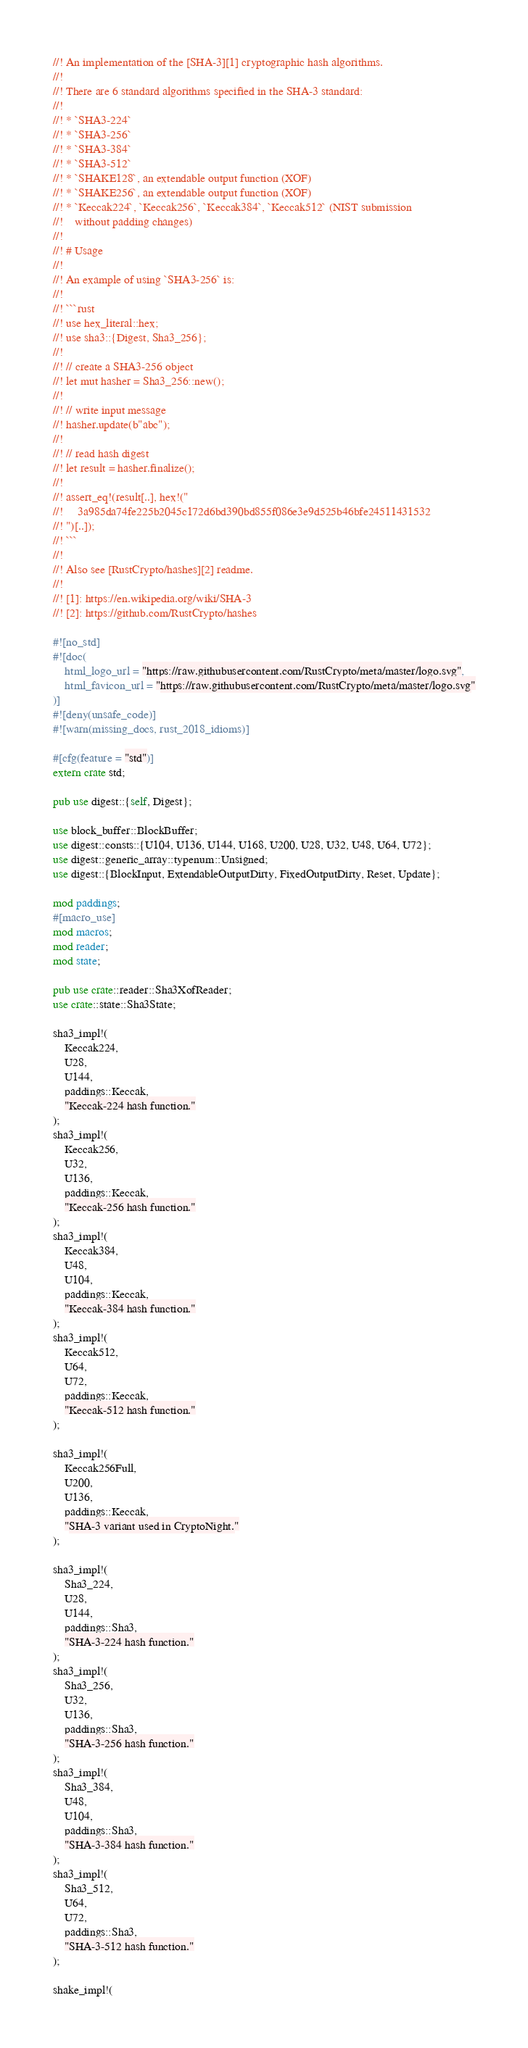Convert code to text. <code><loc_0><loc_0><loc_500><loc_500><_Rust_>//! An implementation of the [SHA-3][1] cryptographic hash algorithms.
//!
//! There are 6 standard algorithms specified in the SHA-3 standard:
//!
//! * `SHA3-224`
//! * `SHA3-256`
//! * `SHA3-384`
//! * `SHA3-512`
//! * `SHAKE128`, an extendable output function (XOF)
//! * `SHAKE256`, an extendable output function (XOF)
//! * `Keccak224`, `Keccak256`, `Keccak384`, `Keccak512` (NIST submission
//!    without padding changes)
//!
//! # Usage
//!
//! An example of using `SHA3-256` is:
//!
//! ```rust
//! use hex_literal::hex;
//! use sha3::{Digest, Sha3_256};
//!
//! // create a SHA3-256 object
//! let mut hasher = Sha3_256::new();
//!
//! // write input message
//! hasher.update(b"abc");
//!
//! // read hash digest
//! let result = hasher.finalize();
//!
//! assert_eq!(result[..], hex!("
//!     3a985da74fe225b2045c172d6bd390bd855f086e3e9d525b46bfe24511431532
//! ")[..]);
//! ```
//!
//! Also see [RustCrypto/hashes][2] readme.
//!
//! [1]: https://en.wikipedia.org/wiki/SHA-3
//! [2]: https://github.com/RustCrypto/hashes

#![no_std]
#![doc(
    html_logo_url = "https://raw.githubusercontent.com/RustCrypto/meta/master/logo.svg",
    html_favicon_url = "https://raw.githubusercontent.com/RustCrypto/meta/master/logo.svg"
)]
#![deny(unsafe_code)]
#![warn(missing_docs, rust_2018_idioms)]

#[cfg(feature = "std")]
extern crate std;

pub use digest::{self, Digest};

use block_buffer::BlockBuffer;
use digest::consts::{U104, U136, U144, U168, U200, U28, U32, U48, U64, U72};
use digest::generic_array::typenum::Unsigned;
use digest::{BlockInput, ExtendableOutputDirty, FixedOutputDirty, Reset, Update};

mod paddings;
#[macro_use]
mod macros;
mod reader;
mod state;

pub use crate::reader::Sha3XofReader;
use crate::state::Sha3State;

sha3_impl!(
    Keccak224,
    U28,
    U144,
    paddings::Keccak,
    "Keccak-224 hash function."
);
sha3_impl!(
    Keccak256,
    U32,
    U136,
    paddings::Keccak,
    "Keccak-256 hash function."
);
sha3_impl!(
    Keccak384,
    U48,
    U104,
    paddings::Keccak,
    "Keccak-384 hash function."
);
sha3_impl!(
    Keccak512,
    U64,
    U72,
    paddings::Keccak,
    "Keccak-512 hash function."
);

sha3_impl!(
    Keccak256Full,
    U200,
    U136,
    paddings::Keccak,
    "SHA-3 variant used in CryptoNight."
);

sha3_impl!(
    Sha3_224,
    U28,
    U144,
    paddings::Sha3,
    "SHA-3-224 hash function."
);
sha3_impl!(
    Sha3_256,
    U32,
    U136,
    paddings::Sha3,
    "SHA-3-256 hash function."
);
sha3_impl!(
    Sha3_384,
    U48,
    U104,
    paddings::Sha3,
    "SHA-3-384 hash function."
);
sha3_impl!(
    Sha3_512,
    U64,
    U72,
    paddings::Sha3,
    "SHA-3-512 hash function."
);

shake_impl!(</code> 